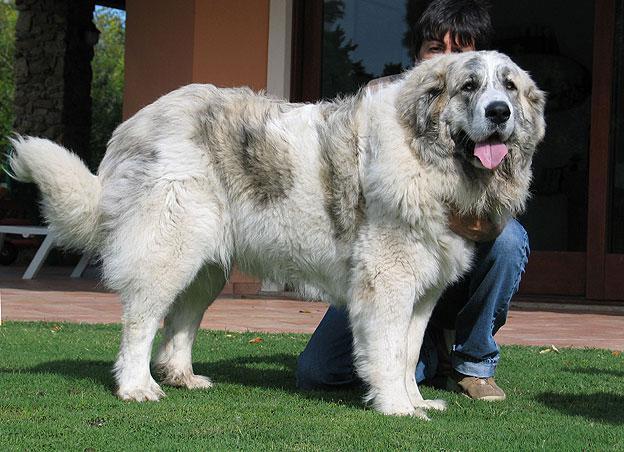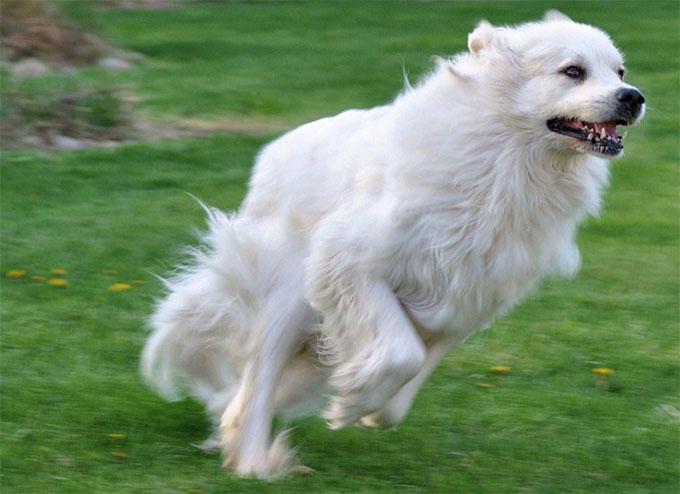The first image is the image on the left, the second image is the image on the right. For the images shown, is this caption "At least one of the dogs is with a human." true? Answer yes or no. Yes. 